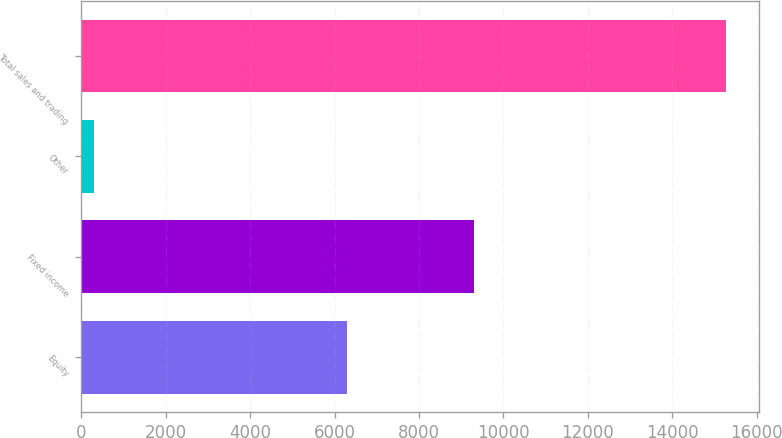Convert chart to OTSL. <chart><loc_0><loc_0><loc_500><loc_500><bar_chart><fcel>Equity<fcel>Fixed income<fcel>Other<fcel>Total sales and trading<nl><fcel>6281<fcel>9291<fcel>288<fcel>15284<nl></chart> 